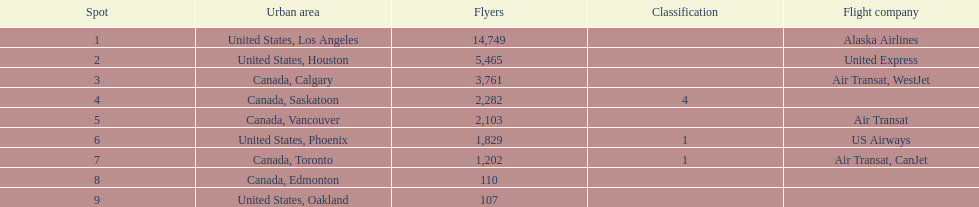Which canadian city had the most passengers traveling from manzanillo international airport in 2013? Calgary. Would you mind parsing the complete table? {'header': ['Spot', 'Urban area', 'Flyers', 'Classification', 'Flight company'], 'rows': [['1', 'United States, Los Angeles', '14,749', '', 'Alaska Airlines'], ['2', 'United States, Houston', '5,465', '', 'United Express'], ['3', 'Canada, Calgary', '3,761', '', 'Air Transat, WestJet'], ['4', 'Canada, Saskatoon', '2,282', '4', ''], ['5', 'Canada, Vancouver', '2,103', '', 'Air Transat'], ['6', 'United States, Phoenix', '1,829', '1', 'US Airways'], ['7', 'Canada, Toronto', '1,202', '1', 'Air Transat, CanJet'], ['8', 'Canada, Edmonton', '110', '', ''], ['9', 'United States, Oakland', '107', '', '']]} 